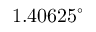<formula> <loc_0><loc_0><loc_500><loc_500>1 . 4 0 6 2 5 ^ { \circ }</formula> 